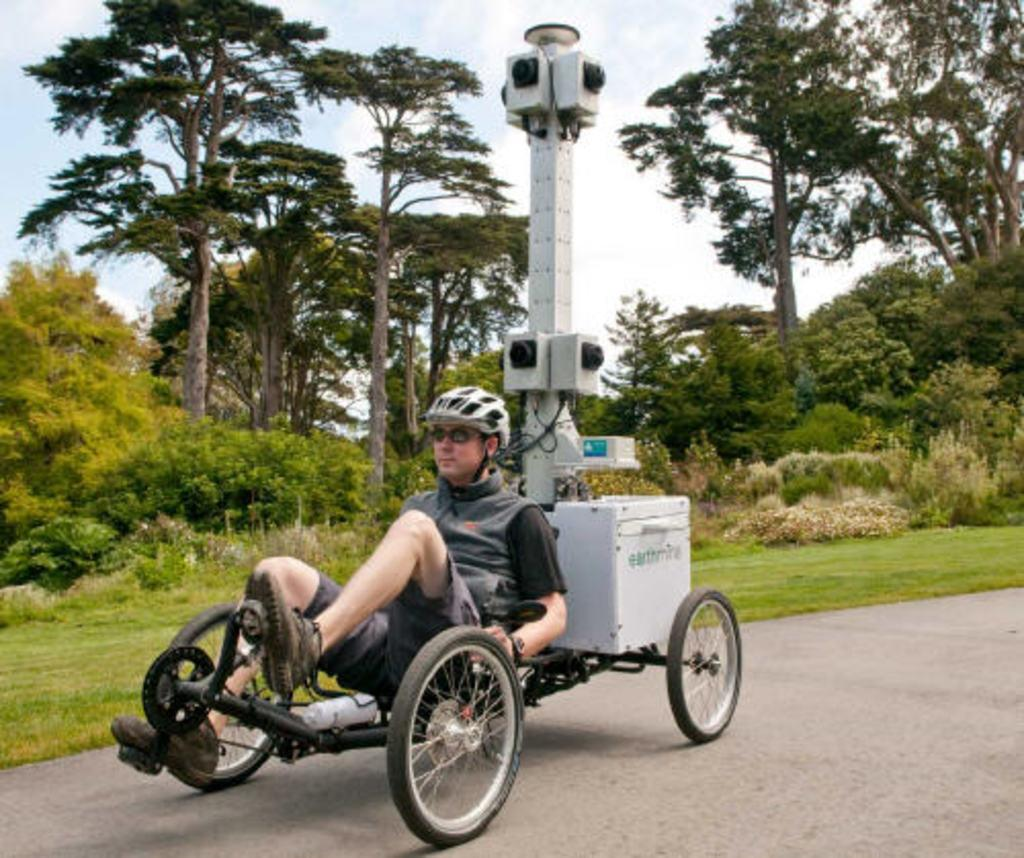What is the person in the image doing? There is a person riding a cart in the image. What can be seen in the background of the image? There are trees in the background of the image. What type of vegetation is visible in the image? There is grass visible in the image. What is the surface on which the cart is moving? There is a road at the bottom of the image. Reasoning: Let' Let's think step by step in order to produce the conversation. We start by identifying the main action in the image, which is the person riding a cart. Then, we describe the background and the type of vegetation present in the image. Finally, we focus on the surface on which the cart is moving, which is the road. Each question is designed to elicit a specific detail about the image that is known from the provided facts. Absurd Question/Answer: What type of thread is being used to hold the cart together in the image? There is no mention of thread or any materials used to hold the cart together in the image. What type of flower can be seen growing on the slope in the image? There is no mention of a slope or any flowers in the image. 